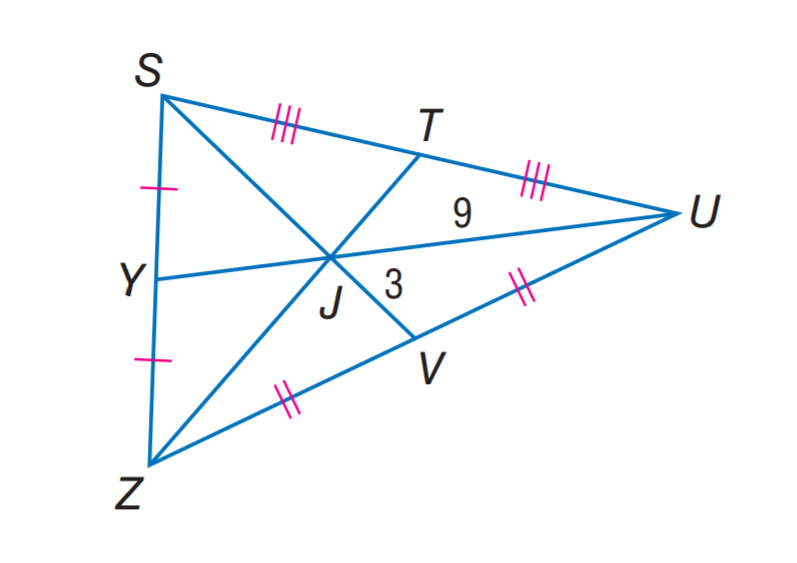Answer the mathemtical geometry problem and directly provide the correct option letter.
Question: U J = 9, V J = 3, and Z T = 18. Find Y J.
Choices: A: 3 B: 4.5 C: 6 D: 9 B 